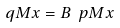<formula> <loc_0><loc_0><loc_500><loc_500>\ q M x = B \ p M x</formula> 